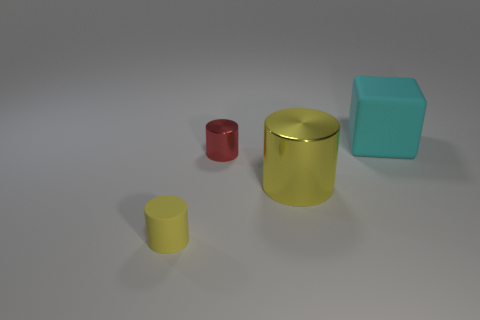Can you describe the lighting in the scene? The lighting in the image is soft and diffused, casting gentle shadows on the surface beneath the objects. This creates a calm atmosphere with a focus on the objects themselves. 